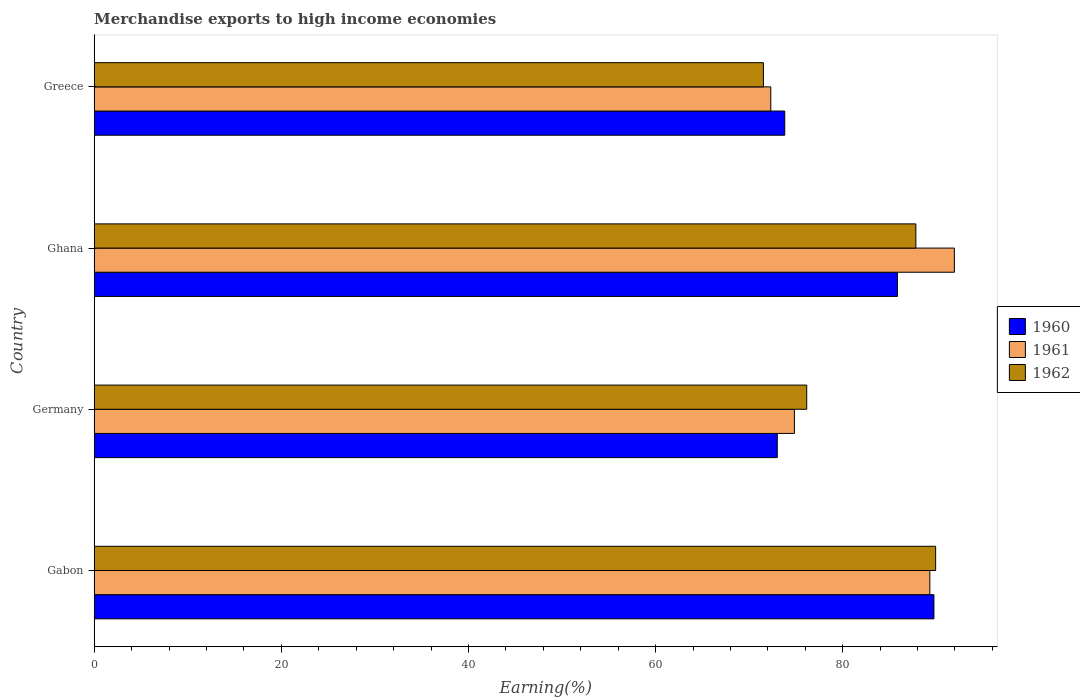In how many cases, is the number of bars for a given country not equal to the number of legend labels?
Your answer should be compact. 0. What is the percentage of amount earned from merchandise exports in 1961 in Germany?
Your answer should be compact. 74.84. Across all countries, what is the maximum percentage of amount earned from merchandise exports in 1961?
Make the answer very short. 91.93. Across all countries, what is the minimum percentage of amount earned from merchandise exports in 1962?
Ensure brevity in your answer.  71.53. In which country was the percentage of amount earned from merchandise exports in 1961 maximum?
Your answer should be compact. Ghana. What is the total percentage of amount earned from merchandise exports in 1961 in the graph?
Your answer should be very brief. 328.4. What is the difference between the percentage of amount earned from merchandise exports in 1960 in Ghana and that in Greece?
Your answer should be very brief. 12.05. What is the difference between the percentage of amount earned from merchandise exports in 1962 in Greece and the percentage of amount earned from merchandise exports in 1960 in Germany?
Offer a very short reply. -1.48. What is the average percentage of amount earned from merchandise exports in 1960 per country?
Offer a very short reply. 80.6. What is the difference between the percentage of amount earned from merchandise exports in 1961 and percentage of amount earned from merchandise exports in 1960 in Gabon?
Offer a very short reply. -0.44. In how many countries, is the percentage of amount earned from merchandise exports in 1960 greater than 40 %?
Provide a short and direct response. 4. What is the ratio of the percentage of amount earned from merchandise exports in 1960 in Gabon to that in Ghana?
Your answer should be compact. 1.05. Is the percentage of amount earned from merchandise exports in 1961 in Germany less than that in Ghana?
Provide a short and direct response. Yes. What is the difference between the highest and the second highest percentage of amount earned from merchandise exports in 1960?
Keep it short and to the point. 3.89. What is the difference between the highest and the lowest percentage of amount earned from merchandise exports in 1961?
Make the answer very short. 19.62. Is the sum of the percentage of amount earned from merchandise exports in 1962 in Gabon and Germany greater than the maximum percentage of amount earned from merchandise exports in 1960 across all countries?
Your answer should be compact. Yes. What does the 1st bar from the top in Ghana represents?
Make the answer very short. 1962. What does the 2nd bar from the bottom in Ghana represents?
Keep it short and to the point. 1961. Are all the bars in the graph horizontal?
Keep it short and to the point. Yes. How many countries are there in the graph?
Ensure brevity in your answer.  4. Are the values on the major ticks of X-axis written in scientific E-notation?
Your answer should be compact. No. Does the graph contain any zero values?
Offer a terse response. No. How many legend labels are there?
Your answer should be compact. 3. What is the title of the graph?
Your response must be concise. Merchandise exports to high income economies. What is the label or title of the X-axis?
Offer a very short reply. Earning(%). What is the Earning(%) of 1960 in Gabon?
Your answer should be very brief. 89.75. What is the Earning(%) in 1961 in Gabon?
Ensure brevity in your answer.  89.31. What is the Earning(%) in 1962 in Gabon?
Your response must be concise. 89.93. What is the Earning(%) of 1960 in Germany?
Provide a succinct answer. 73.01. What is the Earning(%) in 1961 in Germany?
Your answer should be compact. 74.84. What is the Earning(%) of 1962 in Germany?
Your answer should be compact. 76.15. What is the Earning(%) of 1960 in Ghana?
Offer a very short reply. 85.85. What is the Earning(%) in 1961 in Ghana?
Your response must be concise. 91.93. What is the Earning(%) of 1962 in Ghana?
Keep it short and to the point. 87.82. What is the Earning(%) of 1960 in Greece?
Offer a terse response. 73.81. What is the Earning(%) in 1961 in Greece?
Keep it short and to the point. 72.31. What is the Earning(%) in 1962 in Greece?
Your answer should be very brief. 71.53. Across all countries, what is the maximum Earning(%) of 1960?
Your response must be concise. 89.75. Across all countries, what is the maximum Earning(%) in 1961?
Your response must be concise. 91.93. Across all countries, what is the maximum Earning(%) in 1962?
Offer a very short reply. 89.93. Across all countries, what is the minimum Earning(%) in 1960?
Keep it short and to the point. 73.01. Across all countries, what is the minimum Earning(%) of 1961?
Offer a very short reply. 72.31. Across all countries, what is the minimum Earning(%) in 1962?
Ensure brevity in your answer.  71.53. What is the total Earning(%) of 1960 in the graph?
Provide a short and direct response. 322.42. What is the total Earning(%) in 1961 in the graph?
Offer a terse response. 328.4. What is the total Earning(%) in 1962 in the graph?
Make the answer very short. 325.43. What is the difference between the Earning(%) in 1960 in Gabon and that in Germany?
Your answer should be very brief. 16.74. What is the difference between the Earning(%) of 1961 in Gabon and that in Germany?
Make the answer very short. 14.47. What is the difference between the Earning(%) in 1962 in Gabon and that in Germany?
Your response must be concise. 13.78. What is the difference between the Earning(%) in 1960 in Gabon and that in Ghana?
Keep it short and to the point. 3.89. What is the difference between the Earning(%) in 1961 in Gabon and that in Ghana?
Your response must be concise. -2.62. What is the difference between the Earning(%) in 1962 in Gabon and that in Ghana?
Keep it short and to the point. 2.11. What is the difference between the Earning(%) of 1960 in Gabon and that in Greece?
Offer a terse response. 15.94. What is the difference between the Earning(%) in 1961 in Gabon and that in Greece?
Your answer should be compact. 17. What is the difference between the Earning(%) in 1962 in Gabon and that in Greece?
Ensure brevity in your answer.  18.41. What is the difference between the Earning(%) of 1960 in Germany and that in Ghana?
Make the answer very short. -12.85. What is the difference between the Earning(%) of 1961 in Germany and that in Ghana?
Your answer should be compact. -17.09. What is the difference between the Earning(%) in 1962 in Germany and that in Ghana?
Give a very brief answer. -11.66. What is the difference between the Earning(%) in 1960 in Germany and that in Greece?
Offer a very short reply. -0.8. What is the difference between the Earning(%) in 1961 in Germany and that in Greece?
Your answer should be compact. 2.52. What is the difference between the Earning(%) of 1962 in Germany and that in Greece?
Your answer should be very brief. 4.63. What is the difference between the Earning(%) of 1960 in Ghana and that in Greece?
Offer a very short reply. 12.05. What is the difference between the Earning(%) of 1961 in Ghana and that in Greece?
Provide a short and direct response. 19.62. What is the difference between the Earning(%) of 1962 in Ghana and that in Greece?
Offer a terse response. 16.29. What is the difference between the Earning(%) of 1960 in Gabon and the Earning(%) of 1961 in Germany?
Give a very brief answer. 14.91. What is the difference between the Earning(%) in 1960 in Gabon and the Earning(%) in 1962 in Germany?
Offer a terse response. 13.59. What is the difference between the Earning(%) in 1961 in Gabon and the Earning(%) in 1962 in Germany?
Your answer should be very brief. 13.16. What is the difference between the Earning(%) in 1960 in Gabon and the Earning(%) in 1961 in Ghana?
Make the answer very short. -2.18. What is the difference between the Earning(%) of 1960 in Gabon and the Earning(%) of 1962 in Ghana?
Make the answer very short. 1.93. What is the difference between the Earning(%) of 1961 in Gabon and the Earning(%) of 1962 in Ghana?
Your response must be concise. 1.49. What is the difference between the Earning(%) in 1960 in Gabon and the Earning(%) in 1961 in Greece?
Give a very brief answer. 17.43. What is the difference between the Earning(%) in 1960 in Gabon and the Earning(%) in 1962 in Greece?
Give a very brief answer. 18.22. What is the difference between the Earning(%) of 1961 in Gabon and the Earning(%) of 1962 in Greece?
Keep it short and to the point. 17.79. What is the difference between the Earning(%) of 1960 in Germany and the Earning(%) of 1961 in Ghana?
Your answer should be compact. -18.93. What is the difference between the Earning(%) of 1960 in Germany and the Earning(%) of 1962 in Ghana?
Your response must be concise. -14.81. What is the difference between the Earning(%) in 1961 in Germany and the Earning(%) in 1962 in Ghana?
Ensure brevity in your answer.  -12.98. What is the difference between the Earning(%) in 1960 in Germany and the Earning(%) in 1961 in Greece?
Keep it short and to the point. 0.69. What is the difference between the Earning(%) in 1960 in Germany and the Earning(%) in 1962 in Greece?
Your answer should be compact. 1.48. What is the difference between the Earning(%) in 1961 in Germany and the Earning(%) in 1962 in Greece?
Provide a succinct answer. 3.31. What is the difference between the Earning(%) in 1960 in Ghana and the Earning(%) in 1961 in Greece?
Make the answer very short. 13.54. What is the difference between the Earning(%) in 1960 in Ghana and the Earning(%) in 1962 in Greece?
Your answer should be compact. 14.33. What is the difference between the Earning(%) in 1961 in Ghana and the Earning(%) in 1962 in Greece?
Offer a terse response. 20.41. What is the average Earning(%) in 1960 per country?
Your response must be concise. 80.6. What is the average Earning(%) in 1961 per country?
Keep it short and to the point. 82.1. What is the average Earning(%) in 1962 per country?
Provide a succinct answer. 81.36. What is the difference between the Earning(%) of 1960 and Earning(%) of 1961 in Gabon?
Your response must be concise. 0.44. What is the difference between the Earning(%) in 1960 and Earning(%) in 1962 in Gabon?
Make the answer very short. -0.18. What is the difference between the Earning(%) of 1961 and Earning(%) of 1962 in Gabon?
Offer a terse response. -0.62. What is the difference between the Earning(%) of 1960 and Earning(%) of 1961 in Germany?
Provide a short and direct response. -1.83. What is the difference between the Earning(%) in 1960 and Earning(%) in 1962 in Germany?
Ensure brevity in your answer.  -3.15. What is the difference between the Earning(%) in 1961 and Earning(%) in 1962 in Germany?
Your response must be concise. -1.32. What is the difference between the Earning(%) of 1960 and Earning(%) of 1961 in Ghana?
Your answer should be very brief. -6.08. What is the difference between the Earning(%) in 1960 and Earning(%) in 1962 in Ghana?
Offer a terse response. -1.96. What is the difference between the Earning(%) in 1961 and Earning(%) in 1962 in Ghana?
Ensure brevity in your answer.  4.12. What is the difference between the Earning(%) in 1960 and Earning(%) in 1961 in Greece?
Keep it short and to the point. 1.49. What is the difference between the Earning(%) of 1960 and Earning(%) of 1962 in Greece?
Give a very brief answer. 2.28. What is the difference between the Earning(%) in 1961 and Earning(%) in 1962 in Greece?
Offer a terse response. 0.79. What is the ratio of the Earning(%) in 1960 in Gabon to that in Germany?
Offer a very short reply. 1.23. What is the ratio of the Earning(%) of 1961 in Gabon to that in Germany?
Keep it short and to the point. 1.19. What is the ratio of the Earning(%) in 1962 in Gabon to that in Germany?
Your answer should be compact. 1.18. What is the ratio of the Earning(%) of 1960 in Gabon to that in Ghana?
Your answer should be compact. 1.05. What is the ratio of the Earning(%) of 1961 in Gabon to that in Ghana?
Keep it short and to the point. 0.97. What is the ratio of the Earning(%) of 1962 in Gabon to that in Ghana?
Offer a very short reply. 1.02. What is the ratio of the Earning(%) in 1960 in Gabon to that in Greece?
Make the answer very short. 1.22. What is the ratio of the Earning(%) in 1961 in Gabon to that in Greece?
Offer a very short reply. 1.24. What is the ratio of the Earning(%) in 1962 in Gabon to that in Greece?
Your answer should be very brief. 1.26. What is the ratio of the Earning(%) in 1960 in Germany to that in Ghana?
Ensure brevity in your answer.  0.85. What is the ratio of the Earning(%) of 1961 in Germany to that in Ghana?
Offer a terse response. 0.81. What is the ratio of the Earning(%) in 1962 in Germany to that in Ghana?
Give a very brief answer. 0.87. What is the ratio of the Earning(%) in 1960 in Germany to that in Greece?
Keep it short and to the point. 0.99. What is the ratio of the Earning(%) in 1961 in Germany to that in Greece?
Offer a very short reply. 1.03. What is the ratio of the Earning(%) of 1962 in Germany to that in Greece?
Give a very brief answer. 1.06. What is the ratio of the Earning(%) of 1960 in Ghana to that in Greece?
Provide a short and direct response. 1.16. What is the ratio of the Earning(%) in 1961 in Ghana to that in Greece?
Your answer should be very brief. 1.27. What is the ratio of the Earning(%) in 1962 in Ghana to that in Greece?
Your response must be concise. 1.23. What is the difference between the highest and the second highest Earning(%) in 1960?
Your answer should be very brief. 3.89. What is the difference between the highest and the second highest Earning(%) in 1961?
Offer a terse response. 2.62. What is the difference between the highest and the second highest Earning(%) of 1962?
Offer a very short reply. 2.11. What is the difference between the highest and the lowest Earning(%) of 1960?
Offer a very short reply. 16.74. What is the difference between the highest and the lowest Earning(%) in 1961?
Your answer should be compact. 19.62. What is the difference between the highest and the lowest Earning(%) of 1962?
Provide a succinct answer. 18.41. 